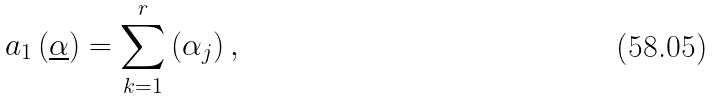Convert formula to latex. <formula><loc_0><loc_0><loc_500><loc_500>a _ { 1 } \left ( \underline { \alpha } \right ) = \sum _ { k = 1 } ^ { r } \left ( \alpha _ { j } \right ) ,</formula> 